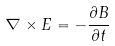<formula> <loc_0><loc_0><loc_500><loc_500>\nabla \times { E } = - \frac { \partial { B } } { \partial t }</formula> 